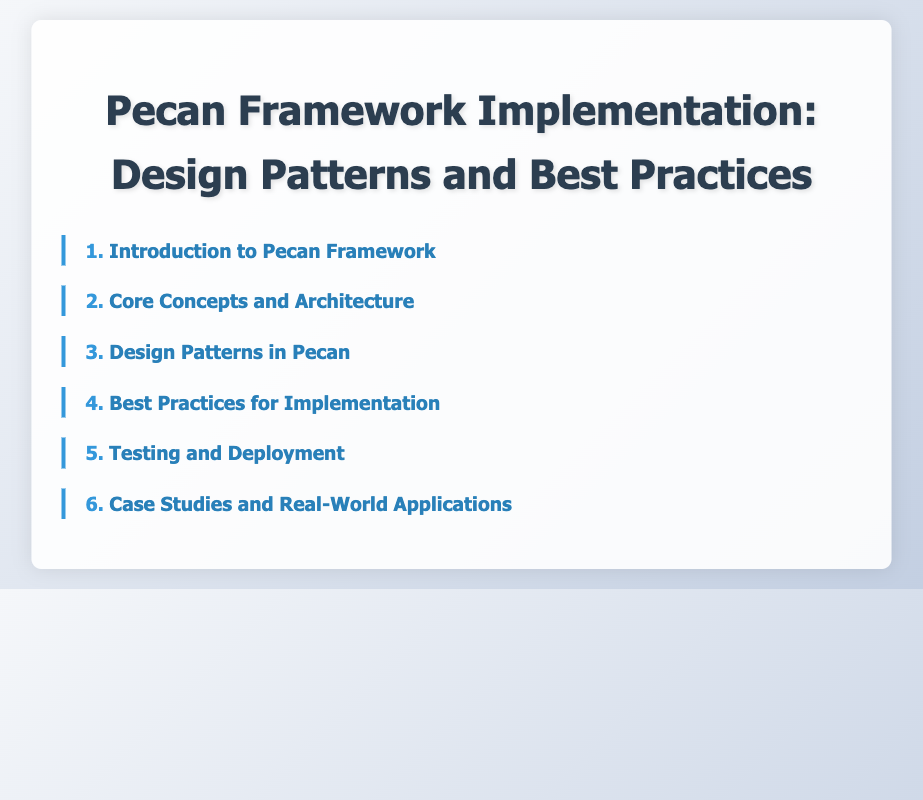What is the first section of the document? The first section is listed at the top of the Table of Contents, which provides a guide to the document's structure.
Answer: Introduction to Pecan Framework How many subsections are in the "Core Concepts and Architecture" section? The number of subsections indicates the depth of the content covered in that section.
Answer: 4 What design pattern is associated with data access in the Pecan Framework? This design pattern focuses on the way that applications access and manage data, which is emphasized in the design patterns section.
Answer: Repository Pattern for Data Access Which section discusses performance optimization? This section contains best practices that help improve the efficiency of applications built with the Pecan Framework.
Answer: Best Practices for Implementation What does CI/CD stand for in the context of deployment? This acronym refers to automation practices mentioned in the testing and deployment section, crucial for modern software development.
Answer: Continuous Integration/Continuous Deployment What is one key feature of the Pecan Framework? Key features provide insights into the framework's capabilities and advantages in web development.
Answer: Flexibility How many total sections are listed in the Table of Contents? The total number of sections indicates the overall organization of the document, offering a glimpse into its coverage.
Answer: 6 What is the final section of the document? The last section provides insight into practical applications of the Pecan Framework through real-world examples.
Answer: Case Studies and Real-World Applications 